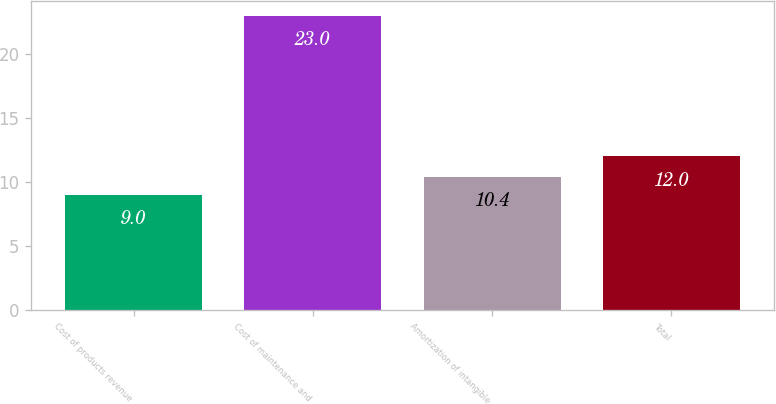<chart> <loc_0><loc_0><loc_500><loc_500><bar_chart><fcel>Cost of products revenue<fcel>Cost of maintenance and<fcel>Amortization of intangible<fcel>Total<nl><fcel>9<fcel>23<fcel>10.4<fcel>12<nl></chart> 